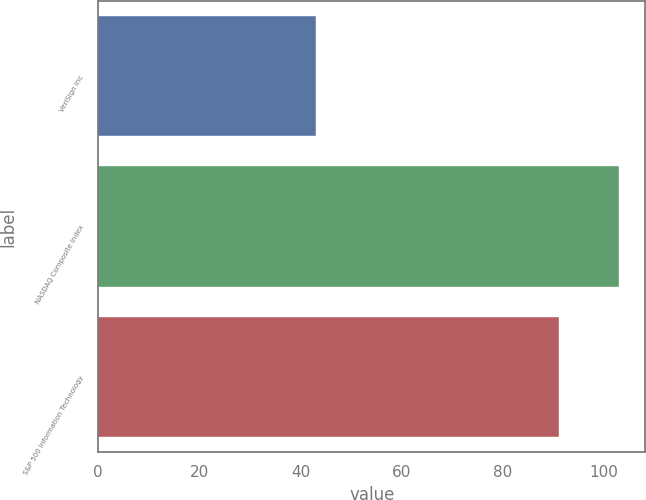Convert chart to OTSL. <chart><loc_0><loc_0><loc_500><loc_500><bar_chart><fcel>VeriSign Inc<fcel>NASDAQ Composite Index<fcel>S&P 500 Information Technology<nl><fcel>43<fcel>103<fcel>91<nl></chart> 